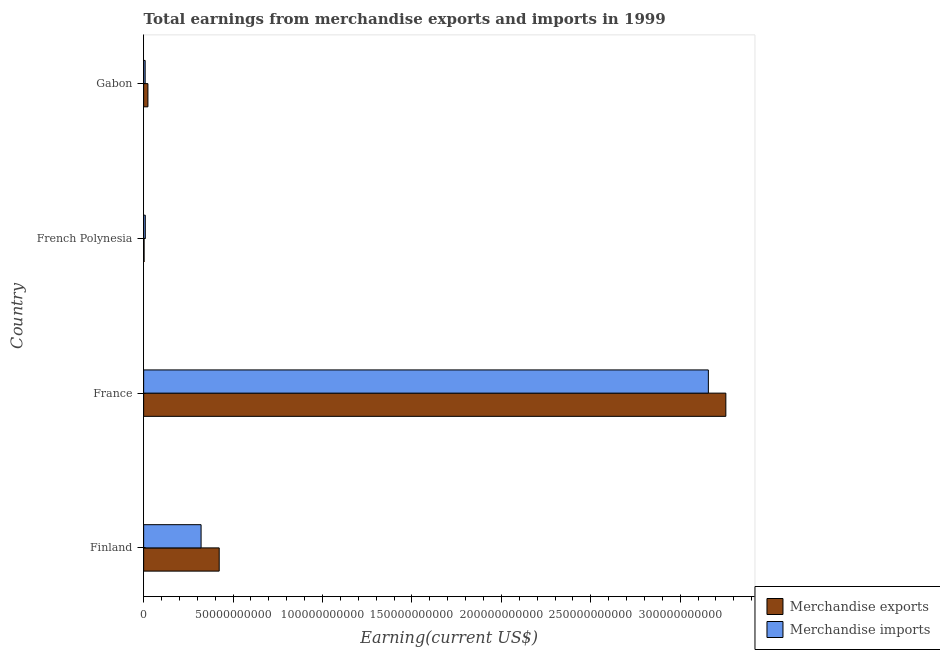How many bars are there on the 2nd tick from the top?
Keep it short and to the point. 2. How many bars are there on the 3rd tick from the bottom?
Provide a short and direct response. 2. What is the label of the 4th group of bars from the top?
Provide a short and direct response. Finland. In how many cases, is the number of bars for a given country not equal to the number of legend labels?
Your answer should be compact. 0. What is the earnings from merchandise imports in Finland?
Make the answer very short. 3.21e+1. Across all countries, what is the maximum earnings from merchandise imports?
Ensure brevity in your answer.  3.16e+11. Across all countries, what is the minimum earnings from merchandise exports?
Ensure brevity in your answer.  2.53e+08. In which country was the earnings from merchandise imports minimum?
Your response must be concise. Gabon. What is the total earnings from merchandise imports in the graph?
Ensure brevity in your answer.  3.50e+11. What is the difference between the earnings from merchandise imports in Finland and that in French Polynesia?
Give a very brief answer. 3.12e+1. What is the difference between the earnings from merchandise imports in Gabon and the earnings from merchandise exports in France?
Provide a succinct answer. -3.25e+11. What is the average earnings from merchandise exports per country?
Offer a terse response. 9.26e+1. What is the difference between the earnings from merchandise exports and earnings from merchandise imports in Gabon?
Your response must be concise. 1.55e+09. In how many countries, is the earnings from merchandise imports greater than 190000000000 US$?
Provide a short and direct response. 1. What is the ratio of the earnings from merchandise exports in Finland to that in France?
Offer a terse response. 0.13. Is the earnings from merchandise imports in France less than that in Gabon?
Provide a short and direct response. No. Is the difference between the earnings from merchandise imports in French Polynesia and Gabon greater than the difference between the earnings from merchandise exports in French Polynesia and Gabon?
Make the answer very short. Yes. What is the difference between the highest and the second highest earnings from merchandise exports?
Provide a short and direct response. 2.83e+11. What is the difference between the highest and the lowest earnings from merchandise imports?
Your answer should be very brief. 3.15e+11. In how many countries, is the earnings from merchandise exports greater than the average earnings from merchandise exports taken over all countries?
Provide a succinct answer. 1. Is the sum of the earnings from merchandise imports in France and French Polynesia greater than the maximum earnings from merchandise exports across all countries?
Your response must be concise. No. What does the 1st bar from the top in Gabon represents?
Provide a short and direct response. Merchandise imports. What does the 1st bar from the bottom in French Polynesia represents?
Give a very brief answer. Merchandise exports. How many countries are there in the graph?
Provide a succinct answer. 4. Are the values on the major ticks of X-axis written in scientific E-notation?
Ensure brevity in your answer.  No. Does the graph contain any zero values?
Make the answer very short. No. How are the legend labels stacked?
Ensure brevity in your answer.  Vertical. What is the title of the graph?
Your response must be concise. Total earnings from merchandise exports and imports in 1999. What is the label or title of the X-axis?
Give a very brief answer. Earning(current US$). What is the label or title of the Y-axis?
Offer a terse response. Country. What is the Earning(current US$) of Merchandise exports in Finland?
Your answer should be compact. 4.22e+1. What is the Earning(current US$) of Merchandise imports in Finland?
Offer a very short reply. 3.21e+1. What is the Earning(current US$) of Merchandise exports in France?
Provide a short and direct response. 3.26e+11. What is the Earning(current US$) of Merchandise imports in France?
Ensure brevity in your answer.  3.16e+11. What is the Earning(current US$) in Merchandise exports in French Polynesia?
Ensure brevity in your answer.  2.53e+08. What is the Earning(current US$) of Merchandise imports in French Polynesia?
Offer a terse response. 9.26e+08. What is the Earning(current US$) of Merchandise exports in Gabon?
Offer a very short reply. 2.39e+09. What is the Earning(current US$) of Merchandise imports in Gabon?
Offer a terse response. 8.41e+08. Across all countries, what is the maximum Earning(current US$) of Merchandise exports?
Your answer should be very brief. 3.26e+11. Across all countries, what is the maximum Earning(current US$) of Merchandise imports?
Your answer should be compact. 3.16e+11. Across all countries, what is the minimum Earning(current US$) of Merchandise exports?
Give a very brief answer. 2.53e+08. Across all countries, what is the minimum Earning(current US$) of Merchandise imports?
Your answer should be very brief. 8.41e+08. What is the total Earning(current US$) in Merchandise exports in the graph?
Your answer should be compact. 3.70e+11. What is the total Earning(current US$) of Merchandise imports in the graph?
Your response must be concise. 3.50e+11. What is the difference between the Earning(current US$) in Merchandise exports in Finland and that in France?
Your answer should be very brief. -2.83e+11. What is the difference between the Earning(current US$) of Merchandise imports in Finland and that in France?
Offer a very short reply. -2.84e+11. What is the difference between the Earning(current US$) in Merchandise exports in Finland and that in French Polynesia?
Offer a terse response. 4.20e+1. What is the difference between the Earning(current US$) of Merchandise imports in Finland and that in French Polynesia?
Keep it short and to the point. 3.12e+1. What is the difference between the Earning(current US$) in Merchandise exports in Finland and that in Gabon?
Give a very brief answer. 3.98e+1. What is the difference between the Earning(current US$) of Merchandise imports in Finland and that in Gabon?
Your response must be concise. 3.13e+1. What is the difference between the Earning(current US$) of Merchandise exports in France and that in French Polynesia?
Keep it short and to the point. 3.25e+11. What is the difference between the Earning(current US$) in Merchandise imports in France and that in French Polynesia?
Give a very brief answer. 3.15e+11. What is the difference between the Earning(current US$) of Merchandise exports in France and that in Gabon?
Your response must be concise. 3.23e+11. What is the difference between the Earning(current US$) of Merchandise imports in France and that in Gabon?
Keep it short and to the point. 3.15e+11. What is the difference between the Earning(current US$) in Merchandise exports in French Polynesia and that in Gabon?
Ensure brevity in your answer.  -2.14e+09. What is the difference between the Earning(current US$) in Merchandise imports in French Polynesia and that in Gabon?
Your response must be concise. 8.50e+07. What is the difference between the Earning(current US$) of Merchandise exports in Finland and the Earning(current US$) of Merchandise imports in France?
Provide a short and direct response. -2.74e+11. What is the difference between the Earning(current US$) of Merchandise exports in Finland and the Earning(current US$) of Merchandise imports in French Polynesia?
Keep it short and to the point. 4.13e+1. What is the difference between the Earning(current US$) in Merchandise exports in Finland and the Earning(current US$) in Merchandise imports in Gabon?
Ensure brevity in your answer.  4.14e+1. What is the difference between the Earning(current US$) in Merchandise exports in France and the Earning(current US$) in Merchandise imports in French Polynesia?
Your answer should be compact. 3.25e+11. What is the difference between the Earning(current US$) in Merchandise exports in France and the Earning(current US$) in Merchandise imports in Gabon?
Your response must be concise. 3.25e+11. What is the difference between the Earning(current US$) in Merchandise exports in French Polynesia and the Earning(current US$) in Merchandise imports in Gabon?
Provide a succinct answer. -5.88e+08. What is the average Earning(current US$) in Merchandise exports per country?
Give a very brief answer. 9.26e+1. What is the average Earning(current US$) of Merchandise imports per country?
Give a very brief answer. 8.74e+1. What is the difference between the Earning(current US$) in Merchandise exports and Earning(current US$) in Merchandise imports in Finland?
Offer a terse response. 1.01e+1. What is the difference between the Earning(current US$) in Merchandise exports and Earning(current US$) in Merchandise imports in France?
Provide a succinct answer. 9.78e+09. What is the difference between the Earning(current US$) of Merchandise exports and Earning(current US$) of Merchandise imports in French Polynesia?
Keep it short and to the point. -6.73e+08. What is the difference between the Earning(current US$) in Merchandise exports and Earning(current US$) in Merchandise imports in Gabon?
Offer a terse response. 1.55e+09. What is the ratio of the Earning(current US$) of Merchandise exports in Finland to that in France?
Your answer should be compact. 0.13. What is the ratio of the Earning(current US$) of Merchandise imports in Finland to that in France?
Provide a short and direct response. 0.1. What is the ratio of the Earning(current US$) in Merchandise exports in Finland to that in French Polynesia?
Make the answer very short. 166.97. What is the ratio of the Earning(current US$) in Merchandise imports in Finland to that in French Polynesia?
Make the answer very short. 34.68. What is the ratio of the Earning(current US$) of Merchandise exports in Finland to that in Gabon?
Your answer should be compact. 17.65. What is the ratio of the Earning(current US$) of Merchandise imports in Finland to that in Gabon?
Your answer should be very brief. 38.19. What is the ratio of the Earning(current US$) in Merchandise exports in France to that in French Polynesia?
Ensure brevity in your answer.  1286.66. What is the ratio of the Earning(current US$) in Merchandise imports in France to that in French Polynesia?
Give a very brief answer. 340.98. What is the ratio of the Earning(current US$) of Merchandise exports in France to that in Gabon?
Provide a succinct answer. 135.98. What is the ratio of the Earning(current US$) of Merchandise imports in France to that in Gabon?
Your response must be concise. 375.44. What is the ratio of the Earning(current US$) in Merchandise exports in French Polynesia to that in Gabon?
Provide a short and direct response. 0.11. What is the ratio of the Earning(current US$) in Merchandise imports in French Polynesia to that in Gabon?
Keep it short and to the point. 1.1. What is the difference between the highest and the second highest Earning(current US$) of Merchandise exports?
Make the answer very short. 2.83e+11. What is the difference between the highest and the second highest Earning(current US$) of Merchandise imports?
Your response must be concise. 2.84e+11. What is the difference between the highest and the lowest Earning(current US$) in Merchandise exports?
Ensure brevity in your answer.  3.25e+11. What is the difference between the highest and the lowest Earning(current US$) of Merchandise imports?
Provide a short and direct response. 3.15e+11. 